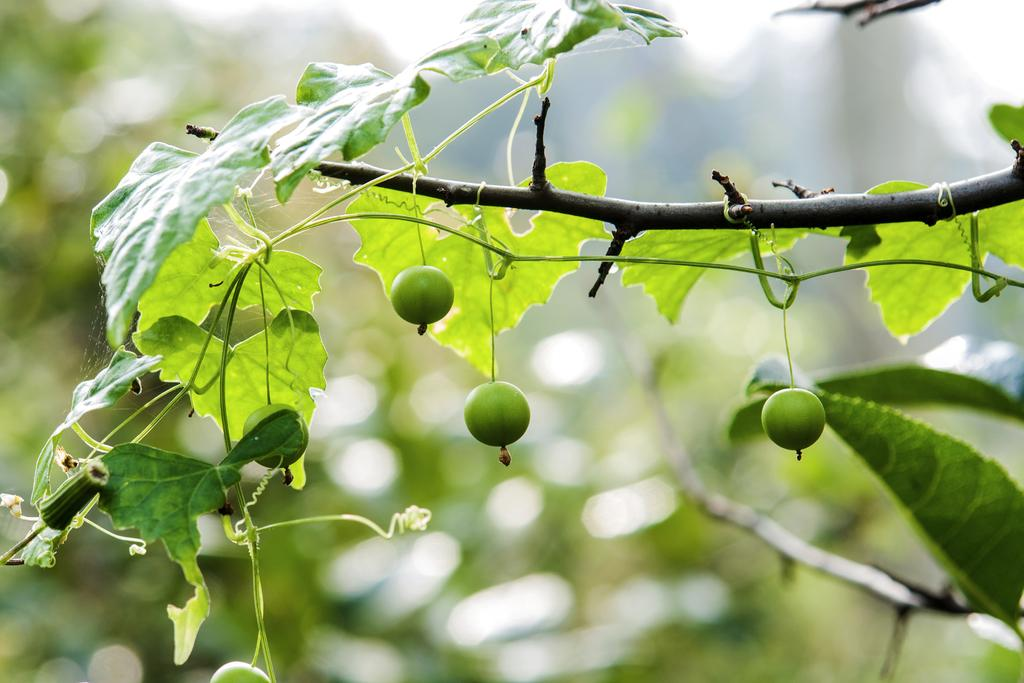What type of plant is in the image? There is an oak plant in the image. What is special about the oak plant in the image? The oak plant has fruits. Where is the oak plant and its fruits located in the image? The oak plant and its fruits are in the center of the image. Can you hear the oak plant laughing in the image? There is no sound or laughter present in the image, as it is a still image of an oak plant with fruits. 